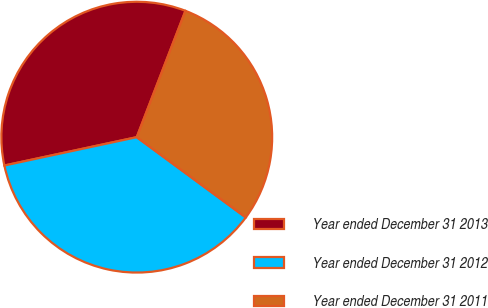Convert chart. <chart><loc_0><loc_0><loc_500><loc_500><pie_chart><fcel>Year ended December 31 2013<fcel>Year ended December 31 2012<fcel>Year ended December 31 2011<nl><fcel>34.21%<fcel>36.54%<fcel>29.24%<nl></chart> 